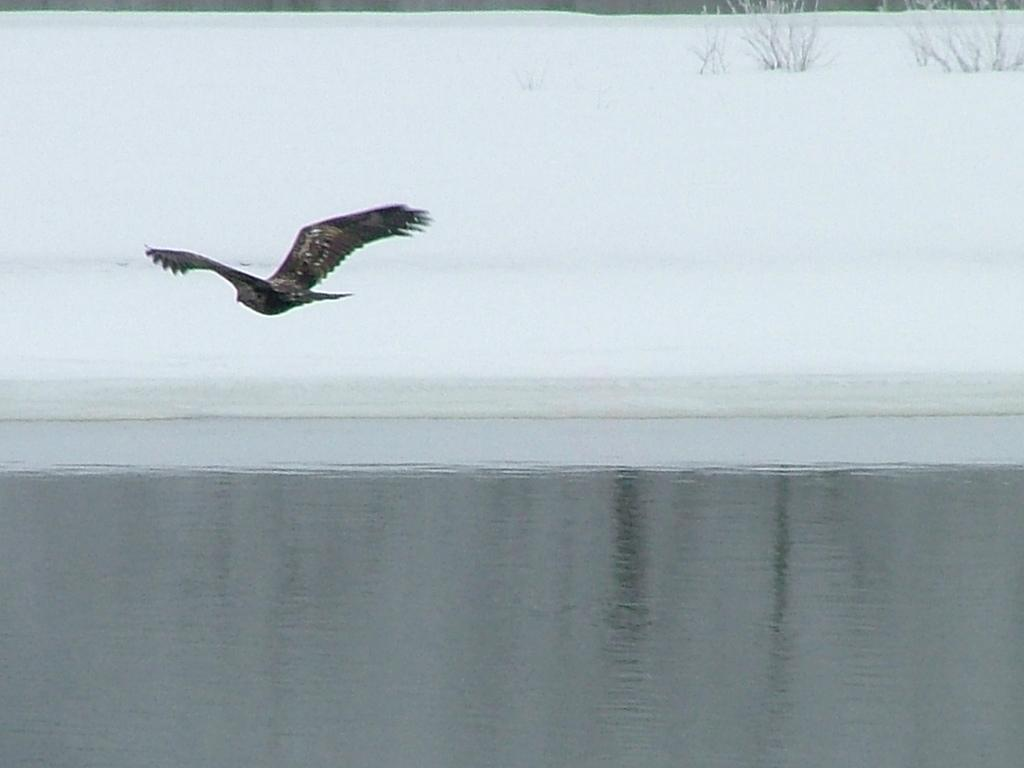What is happening in the sky in the image? There is a bird flying in the air in the image. What is the condition of the land in the background? The land in the background is covered with snow. What type of vegetation can be seen on the right side of the image? There are plants on the right side of the image. What body of water is visible in the front of the image? There is a lake in the front of the image. What type of bushes can be seen growing near the lake in the image? There are no bushes visible in the image; only plants, a bird, snow-covered land, and a lake are present. 